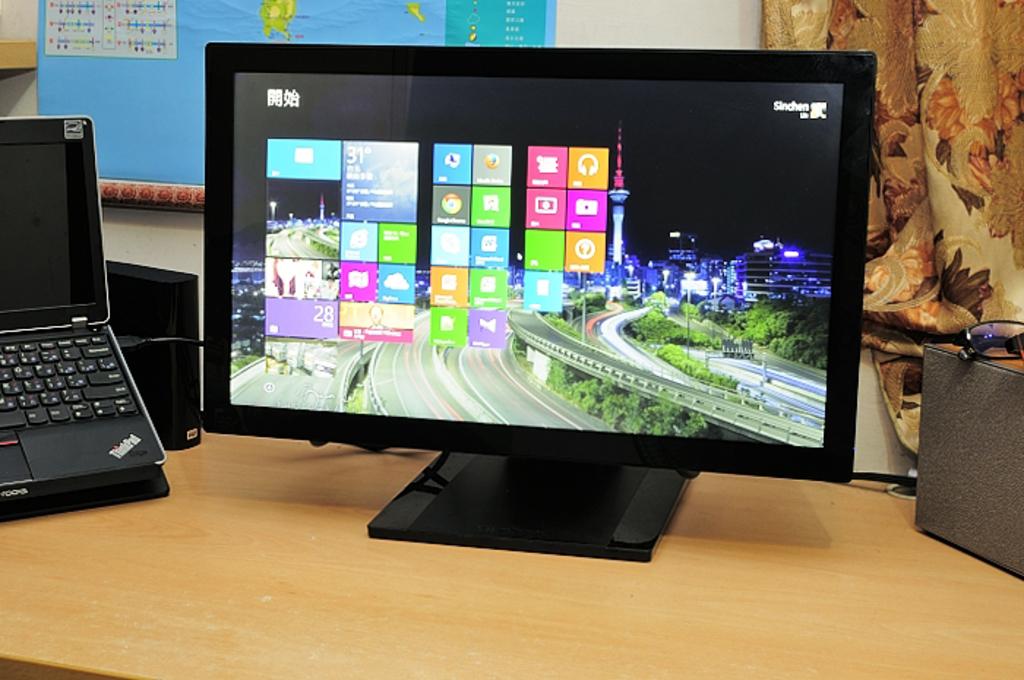What brand of laptop is on the left?
Provide a short and direct response. Thinkpad. 